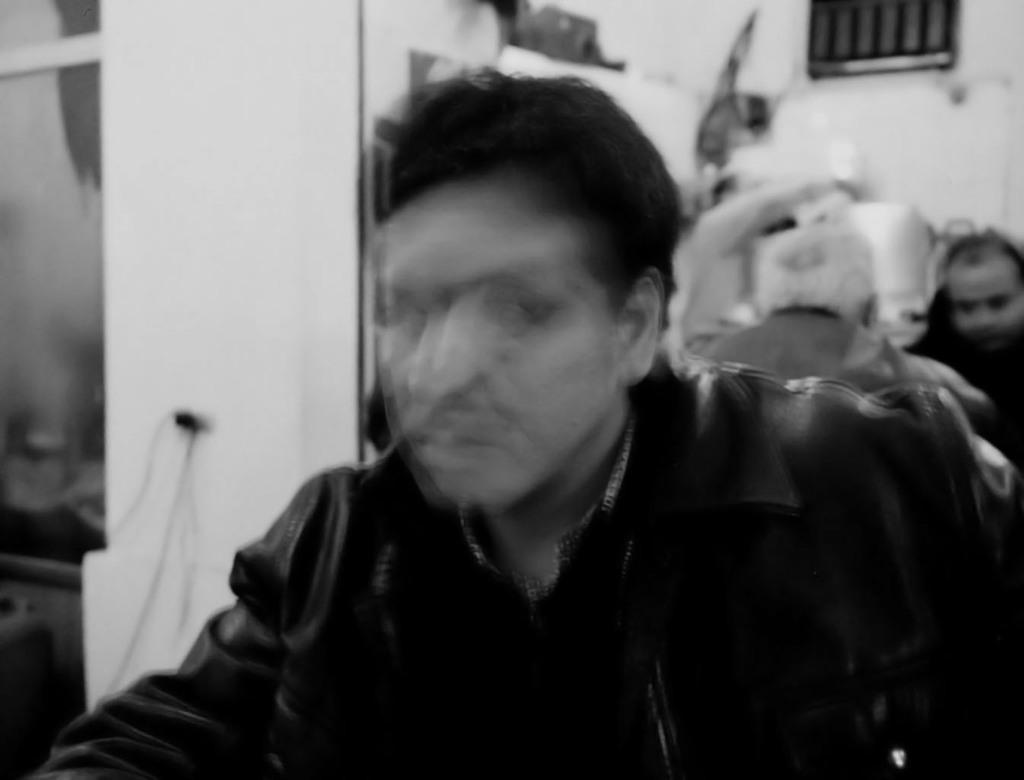How many persons are in the image? There is a group of persons in the image. What are the persons in the image doing? The persons are sitting. What is visible in the background of the image? There is a wall in the image. What type of kite can be seen flying in the winter sky in the image? There is no kite present in the image, nor is there any reference to winter or a sky. 